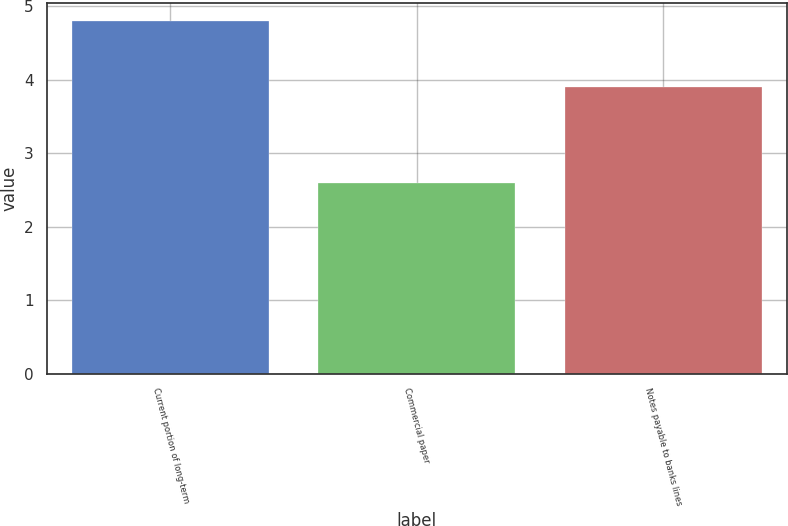Convert chart. <chart><loc_0><loc_0><loc_500><loc_500><bar_chart><fcel>Current portion of long-term<fcel>Commercial paper<fcel>Notes payable to banks lines<nl><fcel>4.8<fcel>2.6<fcel>3.9<nl></chart> 